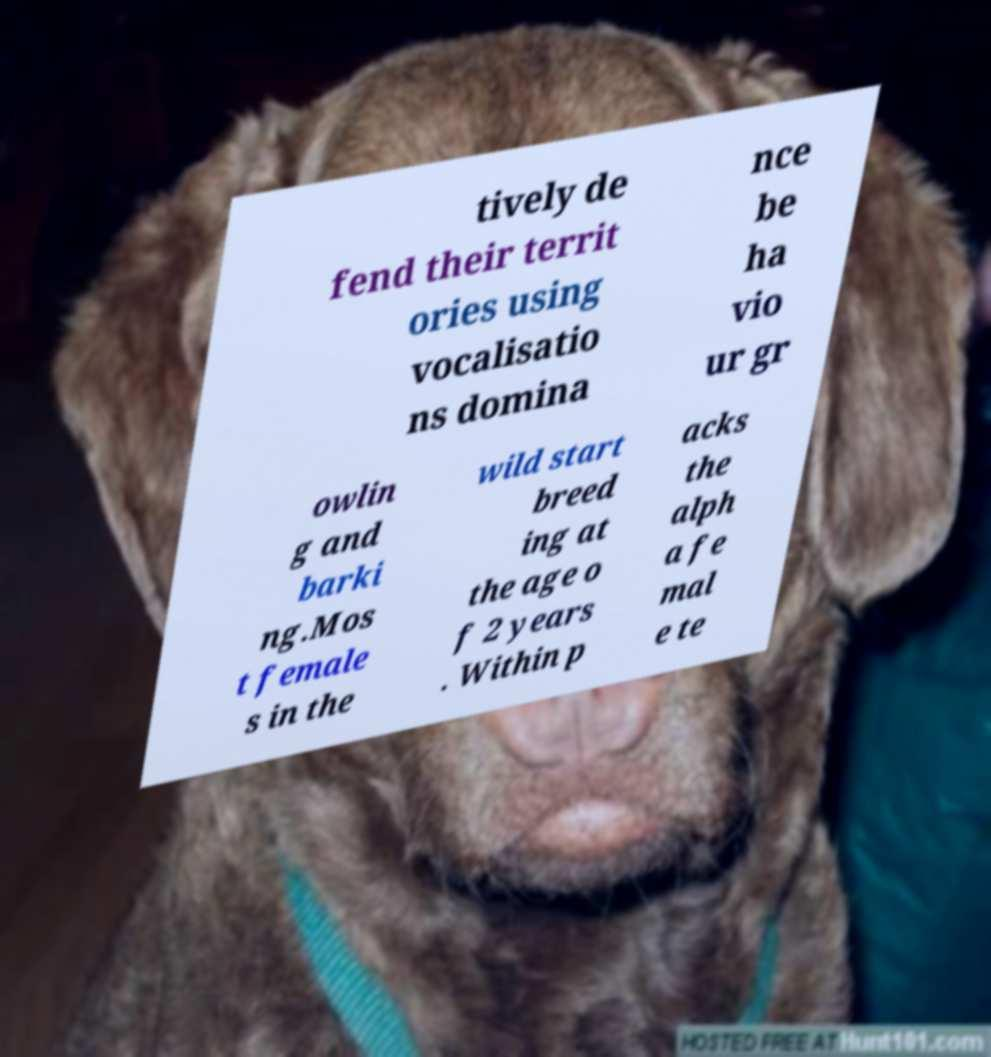What messages or text are displayed in this image? I need them in a readable, typed format. tively de fend their territ ories using vocalisatio ns domina nce be ha vio ur gr owlin g and barki ng.Mos t female s in the wild start breed ing at the age o f 2 years . Within p acks the alph a fe mal e te 